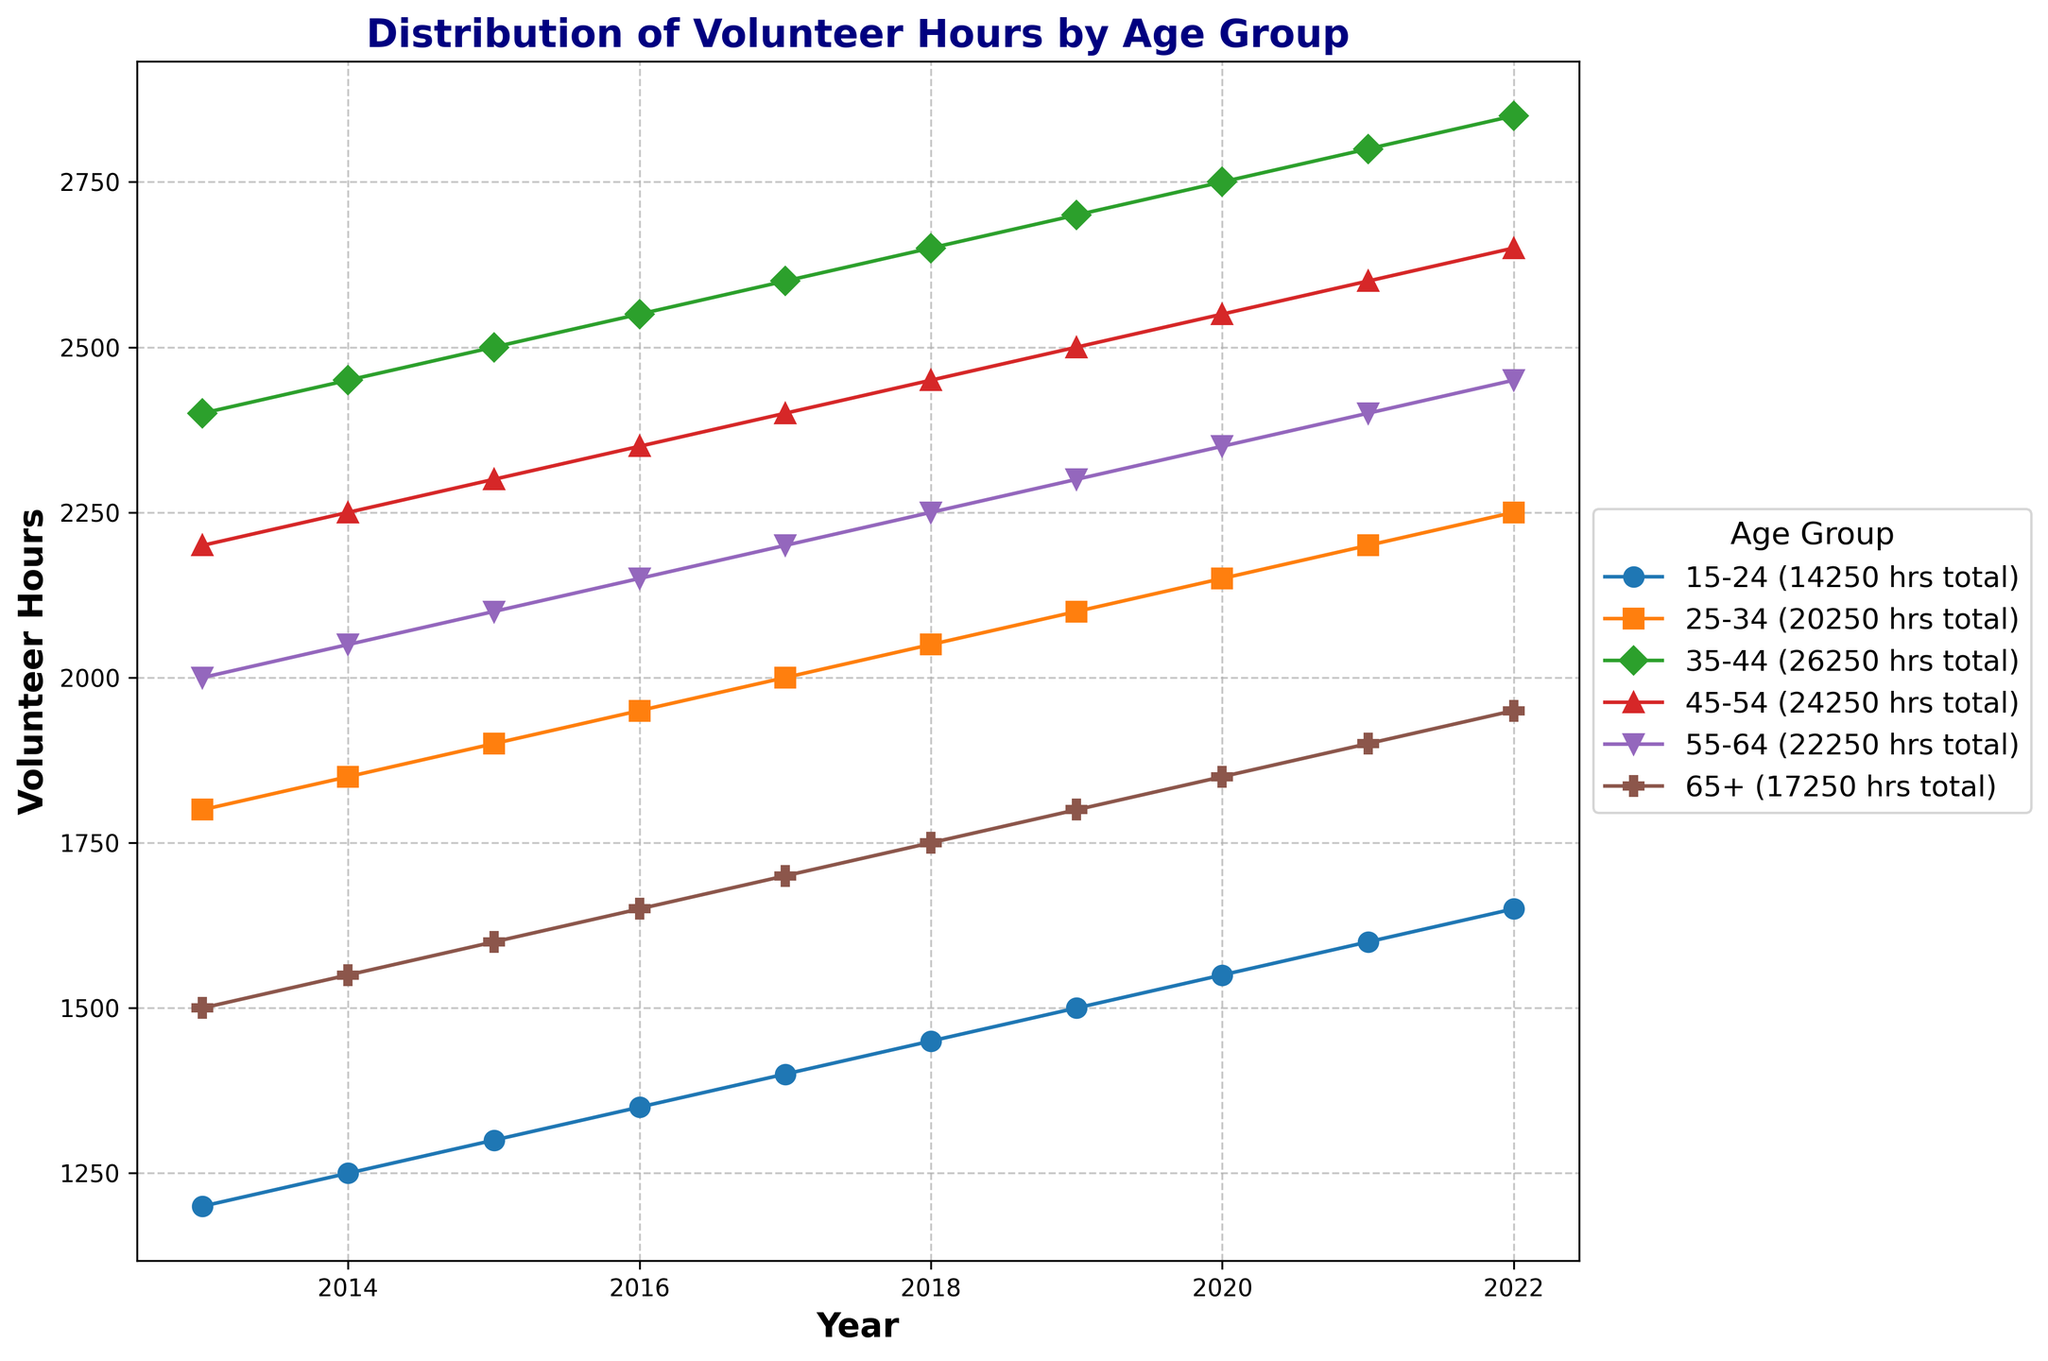What age group contributed the highest total volunteer hours over the entire period? Summing volunteer hours for each age group from 2013-2022, the 35-44 age group contributed the highest total hours (2400 + 2450 + 2500 + 2550 + 2600 + 2650 + 2700 + 2750 + 2800 + 2850) = 26250 hours.
Answer: 35-44 Which age group showed the most consistent yearly increase in volunteer hours? By examining the plot visually, the 35-44 age group showed a clear, steady increase each year. Other age groups had more fluctuations.
Answer: 35-44 How did the volunteer hours for the 65+ age group change from 2013 to 2022? Looking at the plot, the volunteer hours for the 65+ age group in 2013 were 1500 hours and in 2022 were 1950 hours. The difference is 1950 - 1500 = 450 hours.
Answer: Increased by 450 hours Which age group had the steepest increase in volunteer hours between 2015 and 2016? On the plot, from 2015 to 2016, the steepest increase is seen in the 15-24 age group, where hours rose from 1300 to 1350, a change of 50 hours.
Answer: 15-24 What is the average volunteer hours per year for the 25-34 age group? For the 25-34 age group, sum the yearly hours from 2013-2022: (1800 + 1850 + 1900 + 1950 + 2000 + 2050 + 2100 + 2150 + 2200 + 2250) = 20250. The average is 20250 / 10 years = 2025 hours.
Answer: 2025 hours Which year had the highest total volunteer hours across all age groups? Summing hours for each year from the plot, 2022 has the highest total: (1650 + 2250 + 2850 + 2650 + 2450 + 1950) = 13850 hours.
Answer: 2022 Did the age group 45-54 ever surpass 65+ in volunteer hours? By comparing the lines of the two groups on the plot, the 45-54 age group consistently had higher volunteer hours every year compared to the 65+ age group.
Answer: Yes What was the trend in volunteer hours for the 55-64 age group from 2013 to 2022? The plot shows a gradual increase in the 55-64 group's volunteer hours each year from 2013 (2000 hours) to 2022 (2450 hours).
Answer: Increasing Which age group experienced the greatest fluctuation in volunteer hours over the decade? By analyzing the variability in the plot, the 15-24 age group shows the most fluctuation, starting at 1200 hours in 2013 and ending at 1650 hours in 2022, but with various changes in between.
Answer: 15-24 